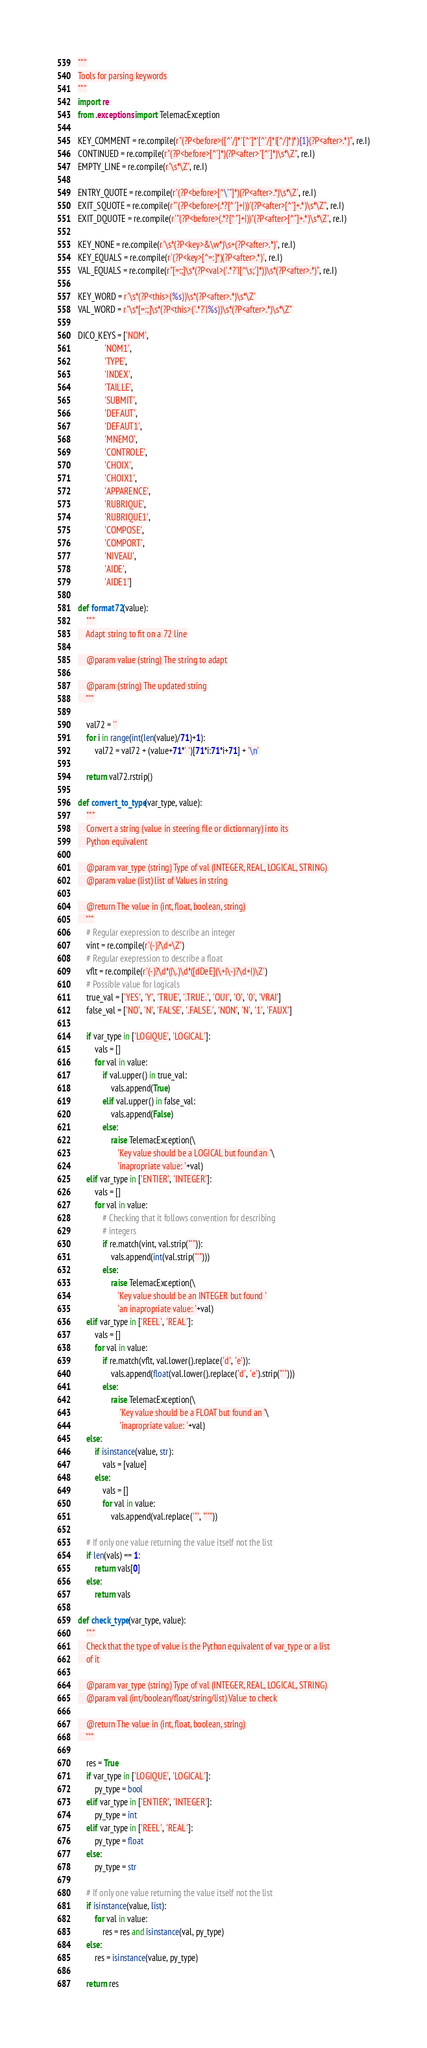<code> <loc_0><loc_0><loc_500><loc_500><_Python_>"""
Tools for parsing keywords
"""
import re
from .exceptions import TelemacException

KEY_COMMENT = re.compile(r"(?P<before>([^'/]*'[^']*'[^'/]*|[^/]*)*){1}(?P<after>.*)", re.I)
CONTINUED = re.compile(r"(?P<before>[^']*)(?P<after>'[^']*)\s*\Z", re.I)
EMPTY_LINE = re.compile(r'\s*\Z', re.I)

ENTRY_QUOTE = re.compile(r'(?P<before>[^\'"]*)(?P<after>.*)\s*\Z', re.I)
EXIT_SQUOTE = re.compile(r"'(?P<before>(.*?[^']+|))'(?P<after>[^']+.*)\s*\Z", re.I)
EXIT_DQUOTE = re.compile(r'"(?P<before>(.*?[^"]+|))"(?P<after>[^"]+.*)\s*\Z', re.I)

KEY_NONE = re.compile(r'\s*(?P<key>&\w*)\s+(?P<after>.*)', re.I)
KEY_EQUALS = re.compile(r'(?P<key>[^=:]*)(?P<after>.*)', re.I)
VAL_EQUALS = re.compile(r"[=:;]\s*(?P<val>('.*?'|[^\s;']*))\s*(?P<after>.*)", re.I)

KEY_WORD = r'\s*(?P<this>(%s))\s*(?P<after>.*)\s*\Z'
VAL_WORD = r"\s*[=:;]\s*(?P<this>('.*?'|%s))\s*(?P<after>.*)\s*\Z"

DICO_KEYS = ['NOM',
             'NOM1',
             'TYPE',
             'INDEX',
             'TAILLE',
             'SUBMIT',
             'DEFAUT',
             'DEFAUT1',
             'MNEMO',
             'CONTROLE',
             'CHOIX',
             'CHOIX1',
             'APPARENCE',
             'RUBRIQUE',
             'RUBRIQUE1',
             'COMPOSE',
             'COMPORT',
             'NIVEAU',
             'AIDE',
             'AIDE1']

def format72(value):
    """
    Adapt string to fit on a 72 line

    @param value (string) The string to adapt

    @param (string) The updated string
    """

    val72 = ''
    for i in range(int(len(value)/71)+1):
        val72 = val72 + (value+71*' ')[71*i:71*i+71] + '\n'

    return val72.rstrip()

def convert_to_type(var_type, value):
    """
    Convert a string (value in steering file or dictionnary) into its
    Python equivalent

    @param var_type (string) Type of val (INTEGER, REAL, LOGICAL, STRING)
    @param value (list) list of Values in string

    @return The value in (int, float, boolean, string)
    """
    # Regular exepression to describe an integer
    vint = re.compile(r'(-)?\d+\Z')
    # Regular exepression to describe a float
    vflt = re.compile(r'(-)?\d*(|\.)\d*([dDeE](\+|\-)?\d+|)\Z')
    # Possible value for logicals
    true_val = ['YES', 'Y', 'TRUE', '.TRUE.', 'OUI', 'O', '0', 'VRAI']
    false_val = ['NO', 'N', 'FALSE', '.FALSE.', 'NON', 'N', '1', 'FAUX']

    if var_type in ['LOGIQUE', 'LOGICAL']:
        vals = []
        for val in value:
            if val.upper() in true_val:
                vals.append(True)
            elif val.upper() in false_val:
                vals.append(False)
            else:
                raise TelemacException(\
                   'Key value should be a LOGICAL but found an '\
                   'inapropriate value: '+val)
    elif var_type in ['ENTIER', 'INTEGER']:
        vals = []
        for val in value:
            # Checking that it follows convention for describing
            # integers
            if re.match(vint, val.strip("'")):
                vals.append(int(val.strip("'")))
            else:
                raise TelemacException(\
                   'Key value should be an INTEGER but found '
                   'an inapropriate value: '+val)
    elif var_type in ['REEL', 'REAL']:
        vals = []
        for val in value:
            if re.match(vflt, val.lower().replace('d', 'e')):
                vals.append(float(val.lower().replace('d', 'e').strip("'")))
            else:
                raise TelemacException(\
                    'Key value should be a FLOAT but found an '\
                    'inapropriate value: '+val)
    else:
        if isinstance(value, str):
            vals = [value]
        else:
            vals = []
            for val in value:
                vals.append(val.replace('"', "''"))

    # If only one value returning the value itself not the list
    if len(vals) == 1:
        return vals[0]
    else:
        return vals

def check_type(var_type, value):
    """
    Check that the type of value is the Python equivalent of var_type or a list
    of it

    @param var_type (string) Type of val (INTEGER, REAL, LOGICAL, STRING)
    @param val (int/boolean/float/string/list) Value to check

    @return The value in (int, float, boolean, string)
    """

    res = True
    if var_type in ['LOGIQUE', 'LOGICAL']:
        py_type = bool
    elif var_type in ['ENTIER', 'INTEGER']:
        py_type = int
    elif var_type in ['REEL', 'REAL']:
        py_type = float
    else:
        py_type = str

    # If only one value returning the value itself not the list
    if isinstance(value, list):
        for val in value:
            res = res and isinstance(val, py_type)
    else:
        res = isinstance(value, py_type)

    return res
</code> 